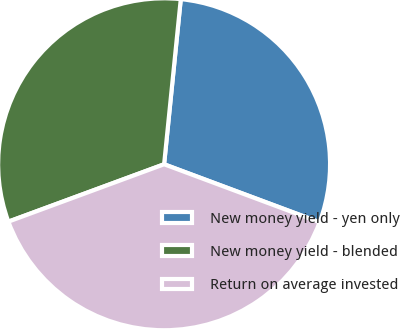Convert chart. <chart><loc_0><loc_0><loc_500><loc_500><pie_chart><fcel>New money yield - yen only<fcel>New money yield - blended<fcel>Return on average invested<nl><fcel>29.08%<fcel>32.22%<fcel>38.7%<nl></chart> 